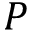Convert formula to latex. <formula><loc_0><loc_0><loc_500><loc_500>P</formula> 